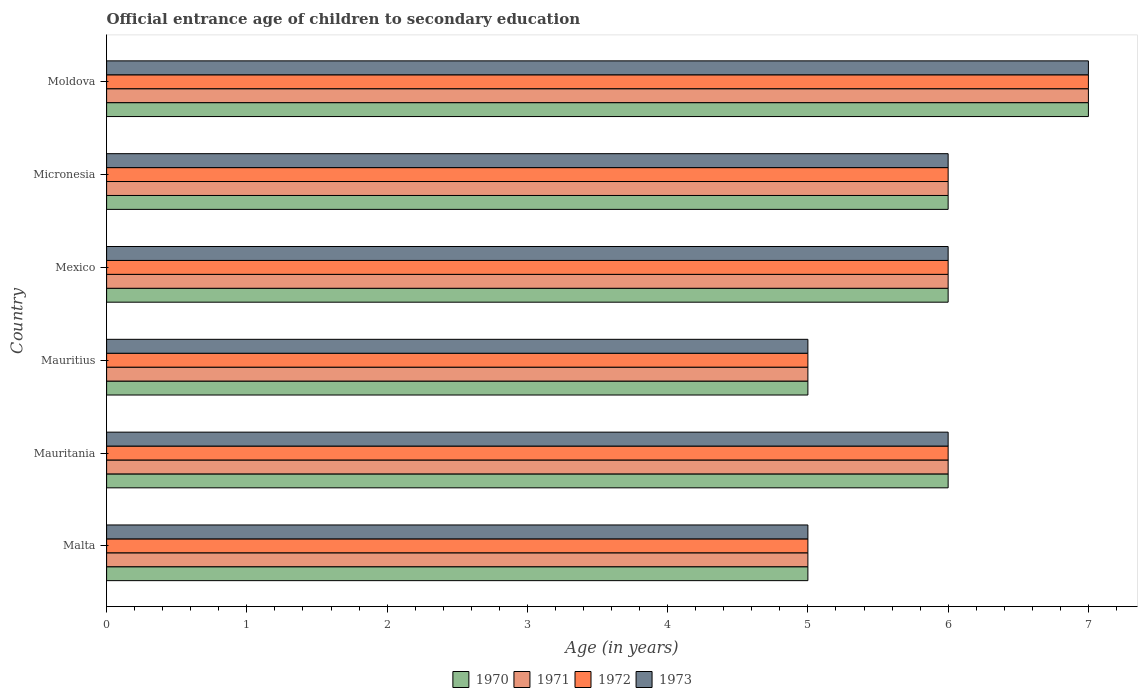How many bars are there on the 4th tick from the top?
Offer a very short reply. 4. What is the label of the 6th group of bars from the top?
Offer a terse response. Malta. In which country was the secondary school starting age of children in 1971 maximum?
Provide a succinct answer. Moldova. In which country was the secondary school starting age of children in 1972 minimum?
Keep it short and to the point. Malta. What is the total secondary school starting age of children in 1970 in the graph?
Your answer should be very brief. 35. What is the difference between the secondary school starting age of children in 1971 in Mauritius and the secondary school starting age of children in 1970 in Mexico?
Provide a succinct answer. -1. What is the average secondary school starting age of children in 1972 per country?
Provide a succinct answer. 5.83. What is the ratio of the secondary school starting age of children in 1970 in Mauritius to that in Micronesia?
Your answer should be very brief. 0.83. How many bars are there?
Provide a succinct answer. 24. How many countries are there in the graph?
Provide a succinct answer. 6. What is the difference between two consecutive major ticks on the X-axis?
Provide a succinct answer. 1. Are the values on the major ticks of X-axis written in scientific E-notation?
Keep it short and to the point. No. Where does the legend appear in the graph?
Provide a short and direct response. Bottom center. How are the legend labels stacked?
Your response must be concise. Horizontal. What is the title of the graph?
Your answer should be compact. Official entrance age of children to secondary education. What is the label or title of the X-axis?
Provide a short and direct response. Age (in years). What is the Age (in years) of 1970 in Malta?
Keep it short and to the point. 5. What is the Age (in years) in 1970 in Mauritania?
Make the answer very short. 6. What is the Age (in years) in 1972 in Mauritania?
Give a very brief answer. 6. What is the Age (in years) of 1971 in Mexico?
Make the answer very short. 6. What is the Age (in years) of 1973 in Mexico?
Your response must be concise. 6. What is the Age (in years) of 1972 in Micronesia?
Offer a terse response. 6. What is the Age (in years) of 1973 in Micronesia?
Provide a succinct answer. 6. What is the Age (in years) of 1971 in Moldova?
Ensure brevity in your answer.  7. Across all countries, what is the maximum Age (in years) of 1973?
Make the answer very short. 7. Across all countries, what is the minimum Age (in years) in 1971?
Provide a succinct answer. 5. Across all countries, what is the minimum Age (in years) of 1973?
Your answer should be very brief. 5. What is the total Age (in years) in 1970 in the graph?
Offer a very short reply. 35. What is the total Age (in years) of 1972 in the graph?
Make the answer very short. 35. What is the difference between the Age (in years) of 1972 in Malta and that in Mauritania?
Offer a terse response. -1. What is the difference between the Age (in years) of 1970 in Malta and that in Mauritius?
Offer a terse response. 0. What is the difference between the Age (in years) in 1971 in Malta and that in Mauritius?
Offer a very short reply. 0. What is the difference between the Age (in years) in 1972 in Malta and that in Mauritius?
Provide a short and direct response. 0. What is the difference between the Age (in years) in 1970 in Malta and that in Mexico?
Your answer should be compact. -1. What is the difference between the Age (in years) of 1970 in Malta and that in Micronesia?
Your answer should be compact. -1. What is the difference between the Age (in years) in 1971 in Malta and that in Micronesia?
Make the answer very short. -1. What is the difference between the Age (in years) in 1970 in Malta and that in Moldova?
Make the answer very short. -2. What is the difference between the Age (in years) in 1971 in Malta and that in Moldova?
Your response must be concise. -2. What is the difference between the Age (in years) in 1972 in Malta and that in Moldova?
Provide a short and direct response. -2. What is the difference between the Age (in years) in 1973 in Malta and that in Moldova?
Make the answer very short. -2. What is the difference between the Age (in years) of 1971 in Mauritania and that in Mauritius?
Your response must be concise. 1. What is the difference between the Age (in years) of 1970 in Mauritania and that in Mexico?
Your answer should be compact. 0. What is the difference between the Age (in years) in 1972 in Mauritania and that in Mexico?
Ensure brevity in your answer.  0. What is the difference between the Age (in years) in 1973 in Mauritania and that in Mexico?
Provide a short and direct response. 0. What is the difference between the Age (in years) in 1972 in Mauritania and that in Micronesia?
Your answer should be very brief. 0. What is the difference between the Age (in years) in 1971 in Mauritania and that in Moldova?
Offer a terse response. -1. What is the difference between the Age (in years) in 1972 in Mauritania and that in Moldova?
Give a very brief answer. -1. What is the difference between the Age (in years) of 1973 in Mauritania and that in Moldova?
Ensure brevity in your answer.  -1. What is the difference between the Age (in years) of 1970 in Mauritius and that in Mexico?
Offer a very short reply. -1. What is the difference between the Age (in years) in 1972 in Mauritius and that in Mexico?
Make the answer very short. -1. What is the difference between the Age (in years) of 1973 in Mauritius and that in Mexico?
Provide a short and direct response. -1. What is the difference between the Age (in years) of 1970 in Mauritius and that in Micronesia?
Offer a very short reply. -1. What is the difference between the Age (in years) in 1973 in Mauritius and that in Micronesia?
Ensure brevity in your answer.  -1. What is the difference between the Age (in years) in 1970 in Mauritius and that in Moldova?
Offer a terse response. -2. What is the difference between the Age (in years) in 1973 in Mauritius and that in Moldova?
Your response must be concise. -2. What is the difference between the Age (in years) in 1970 in Mexico and that in Micronesia?
Provide a succinct answer. 0. What is the difference between the Age (in years) of 1973 in Mexico and that in Micronesia?
Your answer should be compact. 0. What is the difference between the Age (in years) of 1971 in Mexico and that in Moldova?
Provide a succinct answer. -1. What is the difference between the Age (in years) of 1972 in Micronesia and that in Moldova?
Your response must be concise. -1. What is the difference between the Age (in years) of 1970 in Malta and the Age (in years) of 1972 in Mauritania?
Provide a short and direct response. -1. What is the difference between the Age (in years) in 1970 in Malta and the Age (in years) in 1973 in Mauritania?
Offer a terse response. -1. What is the difference between the Age (in years) of 1971 in Malta and the Age (in years) of 1972 in Mauritania?
Offer a terse response. -1. What is the difference between the Age (in years) in 1971 in Malta and the Age (in years) in 1973 in Mauritania?
Give a very brief answer. -1. What is the difference between the Age (in years) of 1972 in Malta and the Age (in years) of 1973 in Mauritania?
Your answer should be compact. -1. What is the difference between the Age (in years) in 1970 in Malta and the Age (in years) in 1971 in Mauritius?
Offer a terse response. 0. What is the difference between the Age (in years) of 1970 in Malta and the Age (in years) of 1972 in Mauritius?
Keep it short and to the point. 0. What is the difference between the Age (in years) of 1970 in Malta and the Age (in years) of 1973 in Mauritius?
Offer a terse response. 0. What is the difference between the Age (in years) in 1971 in Malta and the Age (in years) in 1972 in Mauritius?
Provide a short and direct response. 0. What is the difference between the Age (in years) of 1971 in Malta and the Age (in years) of 1973 in Mauritius?
Your answer should be very brief. 0. What is the difference between the Age (in years) in 1970 in Malta and the Age (in years) in 1971 in Mexico?
Ensure brevity in your answer.  -1. What is the difference between the Age (in years) in 1970 in Malta and the Age (in years) in 1972 in Mexico?
Offer a very short reply. -1. What is the difference between the Age (in years) of 1970 in Malta and the Age (in years) of 1973 in Mexico?
Provide a short and direct response. -1. What is the difference between the Age (in years) of 1971 in Malta and the Age (in years) of 1973 in Mexico?
Make the answer very short. -1. What is the difference between the Age (in years) of 1972 in Malta and the Age (in years) of 1973 in Mexico?
Your response must be concise. -1. What is the difference between the Age (in years) of 1970 in Malta and the Age (in years) of 1973 in Moldova?
Give a very brief answer. -2. What is the difference between the Age (in years) in 1970 in Mauritania and the Age (in years) in 1972 in Mauritius?
Provide a short and direct response. 1. What is the difference between the Age (in years) in 1971 in Mauritania and the Age (in years) in 1972 in Mauritius?
Your answer should be very brief. 1. What is the difference between the Age (in years) in 1970 in Mauritania and the Age (in years) in 1973 in Mexico?
Offer a terse response. 0. What is the difference between the Age (in years) in 1971 in Mauritania and the Age (in years) in 1972 in Mexico?
Offer a terse response. 0. What is the difference between the Age (in years) in 1972 in Mauritania and the Age (in years) in 1973 in Micronesia?
Provide a succinct answer. 0. What is the difference between the Age (in years) in 1970 in Mauritania and the Age (in years) in 1971 in Moldova?
Make the answer very short. -1. What is the difference between the Age (in years) in 1971 in Mauritania and the Age (in years) in 1973 in Moldova?
Your response must be concise. -1. What is the difference between the Age (in years) of 1970 in Mauritius and the Age (in years) of 1971 in Mexico?
Make the answer very short. -1. What is the difference between the Age (in years) of 1970 in Mauritius and the Age (in years) of 1973 in Mexico?
Give a very brief answer. -1. What is the difference between the Age (in years) of 1971 in Mauritius and the Age (in years) of 1972 in Mexico?
Provide a succinct answer. -1. What is the difference between the Age (in years) of 1972 in Mauritius and the Age (in years) of 1973 in Mexico?
Ensure brevity in your answer.  -1. What is the difference between the Age (in years) in 1970 in Mauritius and the Age (in years) in 1973 in Micronesia?
Keep it short and to the point. -1. What is the difference between the Age (in years) in 1971 in Mauritius and the Age (in years) in 1972 in Micronesia?
Your answer should be very brief. -1. What is the difference between the Age (in years) in 1972 in Mauritius and the Age (in years) in 1973 in Micronesia?
Provide a short and direct response. -1. What is the difference between the Age (in years) of 1970 in Mauritius and the Age (in years) of 1972 in Moldova?
Your answer should be very brief. -2. What is the difference between the Age (in years) in 1970 in Mauritius and the Age (in years) in 1973 in Moldova?
Your response must be concise. -2. What is the difference between the Age (in years) of 1971 in Mauritius and the Age (in years) of 1973 in Moldova?
Ensure brevity in your answer.  -2. What is the difference between the Age (in years) of 1972 in Mauritius and the Age (in years) of 1973 in Moldova?
Your response must be concise. -2. What is the difference between the Age (in years) in 1970 in Mexico and the Age (in years) in 1971 in Micronesia?
Give a very brief answer. 0. What is the difference between the Age (in years) of 1970 in Mexico and the Age (in years) of 1972 in Micronesia?
Offer a very short reply. 0. What is the difference between the Age (in years) in 1971 in Mexico and the Age (in years) in 1973 in Micronesia?
Provide a succinct answer. 0. What is the difference between the Age (in years) in 1970 in Mexico and the Age (in years) in 1973 in Moldova?
Give a very brief answer. -1. What is the difference between the Age (in years) in 1971 in Mexico and the Age (in years) in 1972 in Moldova?
Your response must be concise. -1. What is the difference between the Age (in years) of 1972 in Mexico and the Age (in years) of 1973 in Moldova?
Offer a terse response. -1. What is the difference between the Age (in years) of 1970 in Micronesia and the Age (in years) of 1971 in Moldova?
Your response must be concise. -1. What is the difference between the Age (in years) in 1971 in Micronesia and the Age (in years) in 1972 in Moldova?
Keep it short and to the point. -1. What is the average Age (in years) in 1970 per country?
Provide a succinct answer. 5.83. What is the average Age (in years) of 1971 per country?
Your answer should be very brief. 5.83. What is the average Age (in years) of 1972 per country?
Your answer should be compact. 5.83. What is the average Age (in years) of 1973 per country?
Your response must be concise. 5.83. What is the difference between the Age (in years) in 1970 and Age (in years) in 1971 in Malta?
Keep it short and to the point. 0. What is the difference between the Age (in years) of 1970 and Age (in years) of 1972 in Malta?
Your answer should be compact. 0. What is the difference between the Age (in years) of 1970 and Age (in years) of 1973 in Malta?
Provide a short and direct response. 0. What is the difference between the Age (in years) in 1971 and Age (in years) in 1972 in Malta?
Your answer should be compact. 0. What is the difference between the Age (in years) of 1972 and Age (in years) of 1973 in Malta?
Give a very brief answer. 0. What is the difference between the Age (in years) in 1971 and Age (in years) in 1972 in Mauritania?
Your response must be concise. 0. What is the difference between the Age (in years) in 1970 and Age (in years) in 1973 in Mauritius?
Your answer should be compact. 0. What is the difference between the Age (in years) of 1971 and Age (in years) of 1973 in Mauritius?
Your response must be concise. 0. What is the difference between the Age (in years) in 1970 and Age (in years) in 1971 in Mexico?
Provide a succinct answer. 0. What is the difference between the Age (in years) of 1970 and Age (in years) of 1972 in Mexico?
Offer a terse response. 0. What is the difference between the Age (in years) in 1971 and Age (in years) in 1973 in Mexico?
Keep it short and to the point. 0. What is the difference between the Age (in years) in 1972 and Age (in years) in 1973 in Mexico?
Keep it short and to the point. 0. What is the difference between the Age (in years) of 1970 and Age (in years) of 1972 in Micronesia?
Ensure brevity in your answer.  0. What is the difference between the Age (in years) in 1970 and Age (in years) in 1973 in Micronesia?
Provide a short and direct response. 0. What is the difference between the Age (in years) in 1971 and Age (in years) in 1972 in Micronesia?
Your response must be concise. 0. What is the difference between the Age (in years) in 1971 and Age (in years) in 1973 in Micronesia?
Provide a succinct answer. 0. What is the difference between the Age (in years) in 1970 and Age (in years) in 1971 in Moldova?
Your answer should be compact. 0. What is the difference between the Age (in years) in 1971 and Age (in years) in 1973 in Moldova?
Keep it short and to the point. 0. What is the ratio of the Age (in years) in 1971 in Malta to that in Mauritania?
Your answer should be very brief. 0.83. What is the ratio of the Age (in years) of 1971 in Malta to that in Mauritius?
Keep it short and to the point. 1. What is the ratio of the Age (in years) in 1972 in Malta to that in Mexico?
Your response must be concise. 0.83. What is the ratio of the Age (in years) of 1973 in Malta to that in Mexico?
Give a very brief answer. 0.83. What is the ratio of the Age (in years) of 1972 in Malta to that in Micronesia?
Make the answer very short. 0.83. What is the ratio of the Age (in years) in 1973 in Malta to that in Micronesia?
Your answer should be compact. 0.83. What is the ratio of the Age (in years) in 1970 in Malta to that in Moldova?
Offer a terse response. 0.71. What is the ratio of the Age (in years) of 1973 in Malta to that in Moldova?
Offer a terse response. 0.71. What is the ratio of the Age (in years) of 1970 in Mauritania to that in Mauritius?
Offer a very short reply. 1.2. What is the ratio of the Age (in years) of 1972 in Mauritania to that in Mauritius?
Provide a succinct answer. 1.2. What is the ratio of the Age (in years) in 1971 in Mauritania to that in Mexico?
Ensure brevity in your answer.  1. What is the ratio of the Age (in years) of 1973 in Mauritania to that in Mexico?
Provide a succinct answer. 1. What is the ratio of the Age (in years) in 1973 in Mauritania to that in Micronesia?
Your response must be concise. 1. What is the ratio of the Age (in years) of 1971 in Mauritania to that in Moldova?
Your answer should be very brief. 0.86. What is the ratio of the Age (in years) of 1972 in Mauritania to that in Moldova?
Provide a succinct answer. 0.86. What is the ratio of the Age (in years) of 1971 in Mauritius to that in Mexico?
Your answer should be very brief. 0.83. What is the ratio of the Age (in years) in 1972 in Mauritius to that in Mexico?
Your answer should be compact. 0.83. What is the ratio of the Age (in years) of 1973 in Mauritius to that in Mexico?
Keep it short and to the point. 0.83. What is the ratio of the Age (in years) in 1970 in Mauritius to that in Micronesia?
Your response must be concise. 0.83. What is the ratio of the Age (in years) in 1972 in Mauritius to that in Micronesia?
Provide a succinct answer. 0.83. What is the ratio of the Age (in years) of 1970 in Mauritius to that in Moldova?
Your response must be concise. 0.71. What is the ratio of the Age (in years) in 1971 in Mauritius to that in Moldova?
Provide a succinct answer. 0.71. What is the ratio of the Age (in years) in 1973 in Mauritius to that in Moldova?
Your response must be concise. 0.71. What is the ratio of the Age (in years) of 1971 in Mexico to that in Micronesia?
Keep it short and to the point. 1. What is the ratio of the Age (in years) of 1972 in Mexico to that in Moldova?
Your response must be concise. 0.86. What is the ratio of the Age (in years) of 1970 in Micronesia to that in Moldova?
Make the answer very short. 0.86. What is the ratio of the Age (in years) in 1973 in Micronesia to that in Moldova?
Provide a short and direct response. 0.86. What is the difference between the highest and the second highest Age (in years) of 1971?
Offer a terse response. 1. What is the difference between the highest and the lowest Age (in years) of 1970?
Provide a short and direct response. 2. What is the difference between the highest and the lowest Age (in years) in 1971?
Provide a succinct answer. 2. What is the difference between the highest and the lowest Age (in years) in 1973?
Offer a very short reply. 2. 